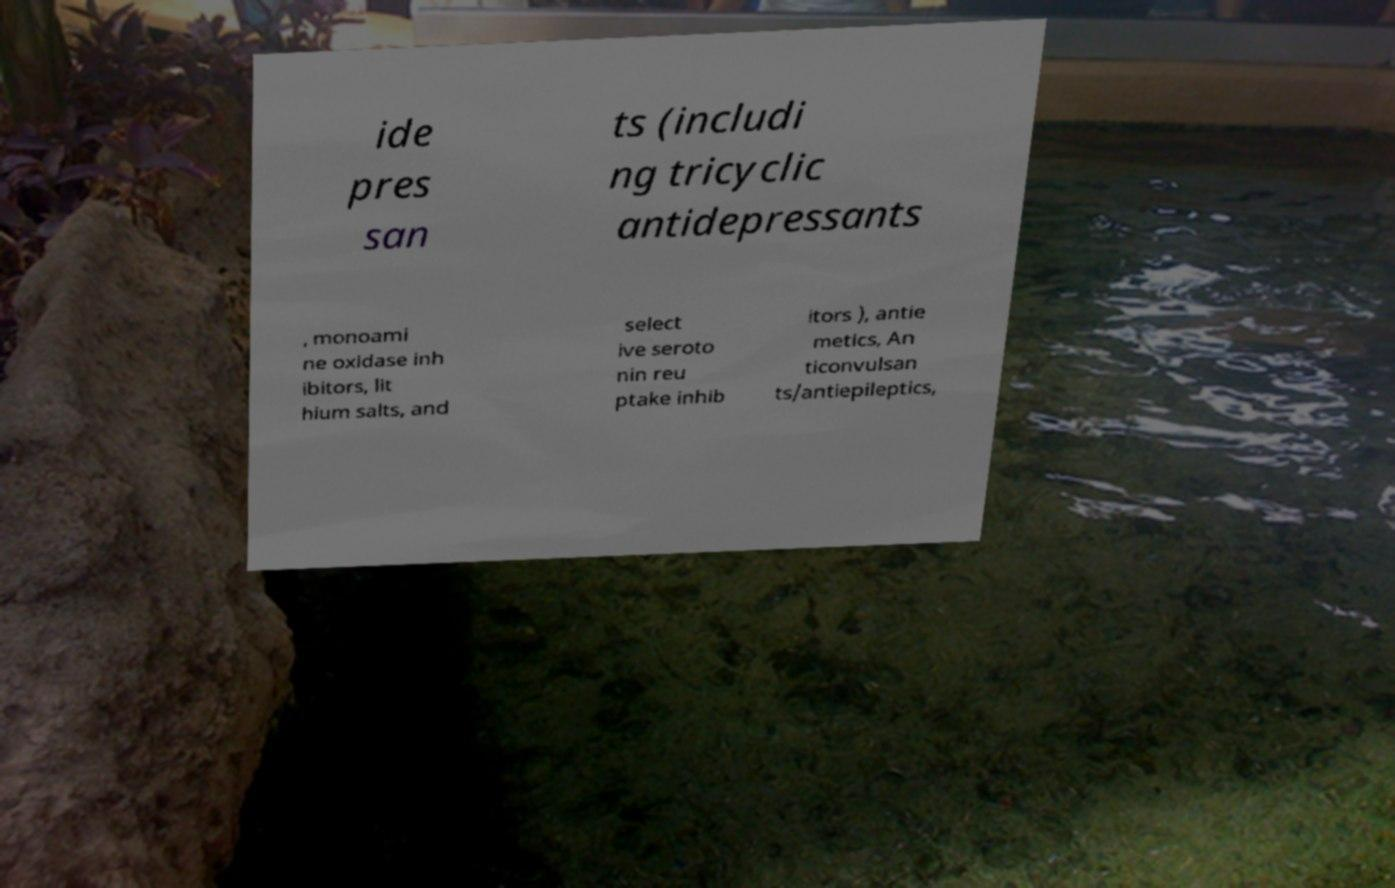Please read and relay the text visible in this image. What does it say? ide pres san ts (includi ng tricyclic antidepressants , monoami ne oxidase inh ibitors, lit hium salts, and select ive seroto nin reu ptake inhib itors ), antie metics, An ticonvulsan ts/antiepileptics, 